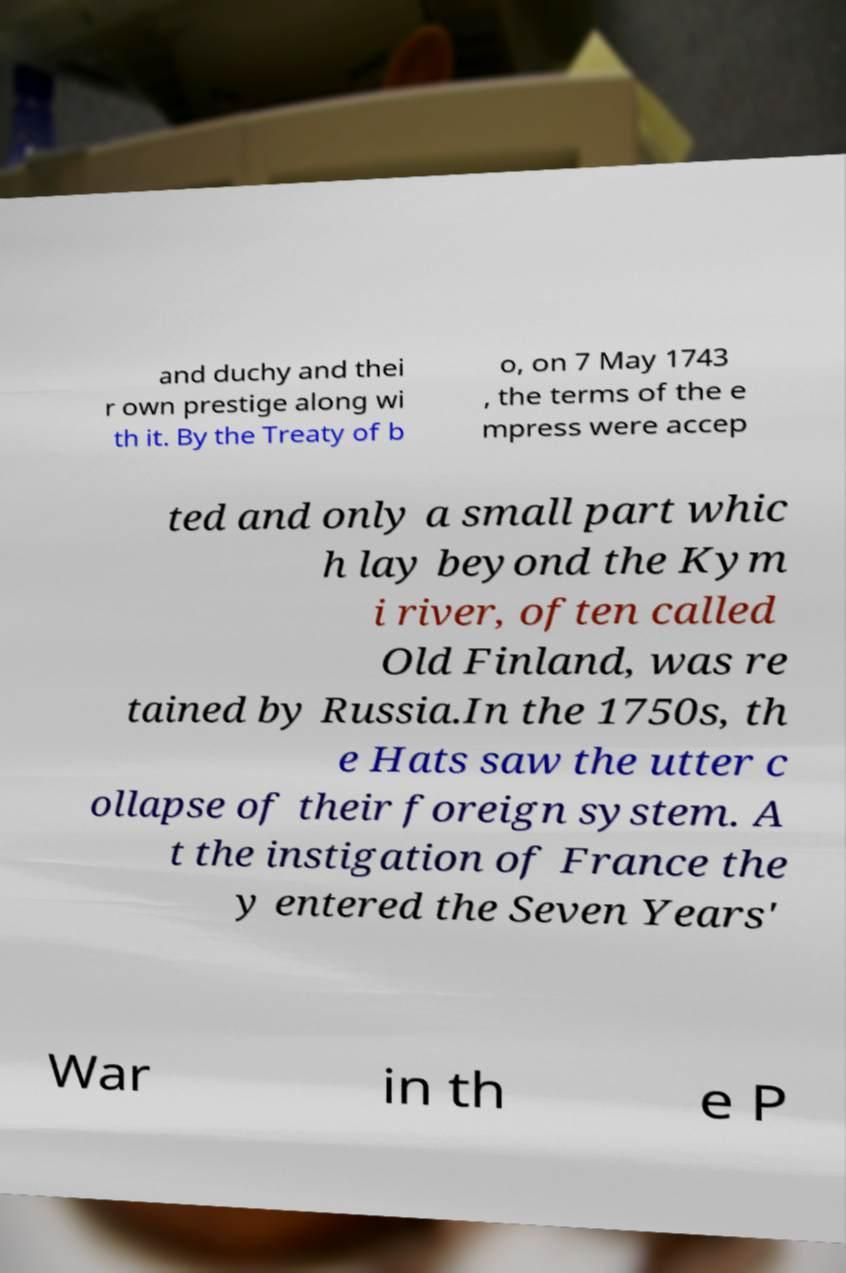What messages or text are displayed in this image? I need them in a readable, typed format. and duchy and thei r own prestige along wi th it. By the Treaty of b o, on 7 May 1743 , the terms of the e mpress were accep ted and only a small part whic h lay beyond the Kym i river, often called Old Finland, was re tained by Russia.In the 1750s, th e Hats saw the utter c ollapse of their foreign system. A t the instigation of France the y entered the Seven Years' War in th e P 